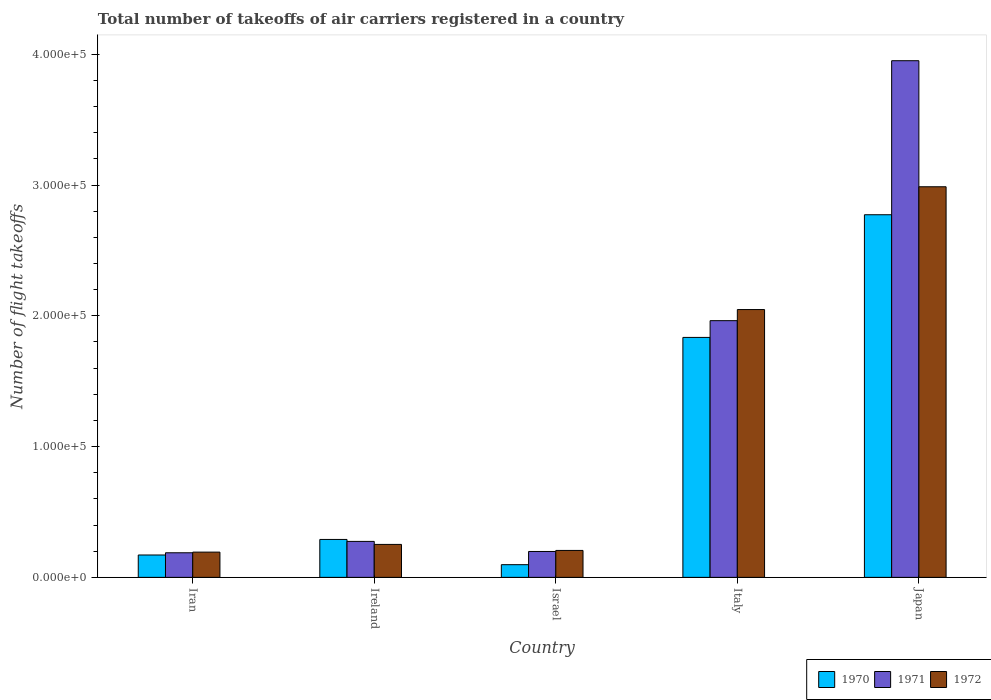How many groups of bars are there?
Ensure brevity in your answer.  5. Are the number of bars on each tick of the X-axis equal?
Your answer should be compact. Yes. How many bars are there on the 4th tick from the right?
Offer a terse response. 3. What is the label of the 2nd group of bars from the left?
Your answer should be very brief. Ireland. In how many cases, is the number of bars for a given country not equal to the number of legend labels?
Your answer should be very brief. 0. What is the total number of flight takeoffs in 1970 in Israel?
Offer a very short reply. 9700. Across all countries, what is the maximum total number of flight takeoffs in 1971?
Your answer should be very brief. 3.95e+05. Across all countries, what is the minimum total number of flight takeoffs in 1972?
Your answer should be very brief. 1.93e+04. In which country was the total number of flight takeoffs in 1971 maximum?
Provide a short and direct response. Japan. In which country was the total number of flight takeoffs in 1971 minimum?
Offer a very short reply. Iran. What is the total total number of flight takeoffs in 1972 in the graph?
Provide a succinct answer. 5.69e+05. What is the difference between the total number of flight takeoffs in 1971 in Iran and that in Japan?
Keep it short and to the point. -3.76e+05. What is the difference between the total number of flight takeoffs in 1970 in Ireland and the total number of flight takeoffs in 1971 in Israel?
Give a very brief answer. 9200. What is the average total number of flight takeoffs in 1972 per country?
Offer a very short reply. 1.14e+05. What is the difference between the total number of flight takeoffs of/in 1972 and total number of flight takeoffs of/in 1970 in Japan?
Keep it short and to the point. 2.14e+04. What is the ratio of the total number of flight takeoffs in 1972 in Iran to that in Israel?
Offer a very short reply. 0.94. What is the difference between the highest and the second highest total number of flight takeoffs in 1970?
Offer a terse response. -1.54e+05. What is the difference between the highest and the lowest total number of flight takeoffs in 1972?
Provide a succinct answer. 2.79e+05. In how many countries, is the total number of flight takeoffs in 1972 greater than the average total number of flight takeoffs in 1972 taken over all countries?
Provide a short and direct response. 2. Are the values on the major ticks of Y-axis written in scientific E-notation?
Ensure brevity in your answer.  Yes. How many legend labels are there?
Offer a very short reply. 3. What is the title of the graph?
Your response must be concise. Total number of takeoffs of air carriers registered in a country. What is the label or title of the X-axis?
Make the answer very short. Country. What is the label or title of the Y-axis?
Offer a very short reply. Number of flight takeoffs. What is the Number of flight takeoffs of 1970 in Iran?
Offer a very short reply. 1.71e+04. What is the Number of flight takeoffs in 1971 in Iran?
Offer a terse response. 1.88e+04. What is the Number of flight takeoffs of 1972 in Iran?
Your answer should be very brief. 1.93e+04. What is the Number of flight takeoffs of 1970 in Ireland?
Provide a succinct answer. 2.90e+04. What is the Number of flight takeoffs of 1971 in Ireland?
Offer a terse response. 2.75e+04. What is the Number of flight takeoffs in 1972 in Ireland?
Your answer should be compact. 2.52e+04. What is the Number of flight takeoffs of 1970 in Israel?
Provide a short and direct response. 9700. What is the Number of flight takeoffs in 1971 in Israel?
Your response must be concise. 1.98e+04. What is the Number of flight takeoffs of 1972 in Israel?
Provide a succinct answer. 2.06e+04. What is the Number of flight takeoffs in 1970 in Italy?
Your answer should be compact. 1.84e+05. What is the Number of flight takeoffs in 1971 in Italy?
Make the answer very short. 1.96e+05. What is the Number of flight takeoffs of 1972 in Italy?
Give a very brief answer. 2.05e+05. What is the Number of flight takeoffs of 1970 in Japan?
Keep it short and to the point. 2.77e+05. What is the Number of flight takeoffs of 1971 in Japan?
Offer a terse response. 3.95e+05. What is the Number of flight takeoffs of 1972 in Japan?
Your response must be concise. 2.99e+05. Across all countries, what is the maximum Number of flight takeoffs in 1970?
Your answer should be compact. 2.77e+05. Across all countries, what is the maximum Number of flight takeoffs in 1971?
Provide a short and direct response. 3.95e+05. Across all countries, what is the maximum Number of flight takeoffs of 1972?
Offer a terse response. 2.99e+05. Across all countries, what is the minimum Number of flight takeoffs of 1970?
Your answer should be very brief. 9700. Across all countries, what is the minimum Number of flight takeoffs in 1971?
Your response must be concise. 1.88e+04. Across all countries, what is the minimum Number of flight takeoffs of 1972?
Give a very brief answer. 1.93e+04. What is the total Number of flight takeoffs in 1970 in the graph?
Your answer should be very brief. 5.17e+05. What is the total Number of flight takeoffs in 1971 in the graph?
Your response must be concise. 6.58e+05. What is the total Number of flight takeoffs in 1972 in the graph?
Your response must be concise. 5.69e+05. What is the difference between the Number of flight takeoffs in 1970 in Iran and that in Ireland?
Make the answer very short. -1.19e+04. What is the difference between the Number of flight takeoffs of 1971 in Iran and that in Ireland?
Provide a succinct answer. -8700. What is the difference between the Number of flight takeoffs in 1972 in Iran and that in Ireland?
Your response must be concise. -5900. What is the difference between the Number of flight takeoffs of 1970 in Iran and that in Israel?
Offer a terse response. 7400. What is the difference between the Number of flight takeoffs in 1971 in Iran and that in Israel?
Your answer should be very brief. -1000. What is the difference between the Number of flight takeoffs of 1972 in Iran and that in Israel?
Offer a very short reply. -1300. What is the difference between the Number of flight takeoffs in 1970 in Iran and that in Italy?
Provide a short and direct response. -1.66e+05. What is the difference between the Number of flight takeoffs in 1971 in Iran and that in Italy?
Offer a terse response. -1.78e+05. What is the difference between the Number of flight takeoffs of 1972 in Iran and that in Italy?
Provide a short and direct response. -1.86e+05. What is the difference between the Number of flight takeoffs of 1970 in Iran and that in Japan?
Provide a short and direct response. -2.60e+05. What is the difference between the Number of flight takeoffs in 1971 in Iran and that in Japan?
Offer a very short reply. -3.76e+05. What is the difference between the Number of flight takeoffs of 1972 in Iran and that in Japan?
Keep it short and to the point. -2.79e+05. What is the difference between the Number of flight takeoffs in 1970 in Ireland and that in Israel?
Make the answer very short. 1.93e+04. What is the difference between the Number of flight takeoffs in 1971 in Ireland and that in Israel?
Your response must be concise. 7700. What is the difference between the Number of flight takeoffs of 1972 in Ireland and that in Israel?
Your answer should be compact. 4600. What is the difference between the Number of flight takeoffs in 1970 in Ireland and that in Italy?
Provide a succinct answer. -1.54e+05. What is the difference between the Number of flight takeoffs of 1971 in Ireland and that in Italy?
Offer a terse response. -1.69e+05. What is the difference between the Number of flight takeoffs in 1972 in Ireland and that in Italy?
Ensure brevity in your answer.  -1.80e+05. What is the difference between the Number of flight takeoffs of 1970 in Ireland and that in Japan?
Your answer should be very brief. -2.48e+05. What is the difference between the Number of flight takeoffs in 1971 in Ireland and that in Japan?
Offer a terse response. -3.68e+05. What is the difference between the Number of flight takeoffs in 1972 in Ireland and that in Japan?
Provide a short and direct response. -2.74e+05. What is the difference between the Number of flight takeoffs of 1970 in Israel and that in Italy?
Your answer should be compact. -1.74e+05. What is the difference between the Number of flight takeoffs of 1971 in Israel and that in Italy?
Your answer should be compact. -1.76e+05. What is the difference between the Number of flight takeoffs in 1972 in Israel and that in Italy?
Keep it short and to the point. -1.84e+05. What is the difference between the Number of flight takeoffs in 1970 in Israel and that in Japan?
Offer a very short reply. -2.68e+05. What is the difference between the Number of flight takeoffs in 1971 in Israel and that in Japan?
Give a very brief answer. -3.75e+05. What is the difference between the Number of flight takeoffs in 1972 in Israel and that in Japan?
Your response must be concise. -2.78e+05. What is the difference between the Number of flight takeoffs in 1970 in Italy and that in Japan?
Keep it short and to the point. -9.38e+04. What is the difference between the Number of flight takeoffs in 1971 in Italy and that in Japan?
Give a very brief answer. -1.99e+05. What is the difference between the Number of flight takeoffs in 1972 in Italy and that in Japan?
Give a very brief answer. -9.39e+04. What is the difference between the Number of flight takeoffs in 1970 in Iran and the Number of flight takeoffs in 1971 in Ireland?
Ensure brevity in your answer.  -1.04e+04. What is the difference between the Number of flight takeoffs of 1970 in Iran and the Number of flight takeoffs of 1972 in Ireland?
Provide a short and direct response. -8100. What is the difference between the Number of flight takeoffs of 1971 in Iran and the Number of flight takeoffs of 1972 in Ireland?
Your response must be concise. -6400. What is the difference between the Number of flight takeoffs of 1970 in Iran and the Number of flight takeoffs of 1971 in Israel?
Provide a succinct answer. -2700. What is the difference between the Number of flight takeoffs of 1970 in Iran and the Number of flight takeoffs of 1972 in Israel?
Your answer should be very brief. -3500. What is the difference between the Number of flight takeoffs in 1971 in Iran and the Number of flight takeoffs in 1972 in Israel?
Offer a terse response. -1800. What is the difference between the Number of flight takeoffs of 1970 in Iran and the Number of flight takeoffs of 1971 in Italy?
Offer a very short reply. -1.79e+05. What is the difference between the Number of flight takeoffs of 1970 in Iran and the Number of flight takeoffs of 1972 in Italy?
Keep it short and to the point. -1.88e+05. What is the difference between the Number of flight takeoffs of 1971 in Iran and the Number of flight takeoffs of 1972 in Italy?
Your answer should be very brief. -1.86e+05. What is the difference between the Number of flight takeoffs in 1970 in Iran and the Number of flight takeoffs in 1971 in Japan?
Your answer should be compact. -3.78e+05. What is the difference between the Number of flight takeoffs of 1970 in Iran and the Number of flight takeoffs of 1972 in Japan?
Provide a succinct answer. -2.82e+05. What is the difference between the Number of flight takeoffs in 1971 in Iran and the Number of flight takeoffs in 1972 in Japan?
Offer a very short reply. -2.80e+05. What is the difference between the Number of flight takeoffs of 1970 in Ireland and the Number of flight takeoffs of 1971 in Israel?
Offer a terse response. 9200. What is the difference between the Number of flight takeoffs in 1970 in Ireland and the Number of flight takeoffs in 1972 in Israel?
Offer a terse response. 8400. What is the difference between the Number of flight takeoffs in 1971 in Ireland and the Number of flight takeoffs in 1972 in Israel?
Your response must be concise. 6900. What is the difference between the Number of flight takeoffs in 1970 in Ireland and the Number of flight takeoffs in 1971 in Italy?
Provide a succinct answer. -1.67e+05. What is the difference between the Number of flight takeoffs in 1970 in Ireland and the Number of flight takeoffs in 1972 in Italy?
Provide a succinct answer. -1.76e+05. What is the difference between the Number of flight takeoffs in 1971 in Ireland and the Number of flight takeoffs in 1972 in Italy?
Offer a very short reply. -1.77e+05. What is the difference between the Number of flight takeoffs of 1970 in Ireland and the Number of flight takeoffs of 1971 in Japan?
Your answer should be compact. -3.66e+05. What is the difference between the Number of flight takeoffs in 1970 in Ireland and the Number of flight takeoffs in 1972 in Japan?
Ensure brevity in your answer.  -2.70e+05. What is the difference between the Number of flight takeoffs in 1971 in Ireland and the Number of flight takeoffs in 1972 in Japan?
Your answer should be very brief. -2.71e+05. What is the difference between the Number of flight takeoffs of 1970 in Israel and the Number of flight takeoffs of 1971 in Italy?
Your response must be concise. -1.87e+05. What is the difference between the Number of flight takeoffs in 1970 in Israel and the Number of flight takeoffs in 1972 in Italy?
Provide a short and direct response. -1.95e+05. What is the difference between the Number of flight takeoffs in 1971 in Israel and the Number of flight takeoffs in 1972 in Italy?
Give a very brief answer. -1.85e+05. What is the difference between the Number of flight takeoffs of 1970 in Israel and the Number of flight takeoffs of 1971 in Japan?
Keep it short and to the point. -3.85e+05. What is the difference between the Number of flight takeoffs of 1970 in Israel and the Number of flight takeoffs of 1972 in Japan?
Your answer should be very brief. -2.89e+05. What is the difference between the Number of flight takeoffs in 1971 in Israel and the Number of flight takeoffs in 1972 in Japan?
Your answer should be compact. -2.79e+05. What is the difference between the Number of flight takeoffs in 1970 in Italy and the Number of flight takeoffs in 1971 in Japan?
Offer a very short reply. -2.12e+05. What is the difference between the Number of flight takeoffs of 1970 in Italy and the Number of flight takeoffs of 1972 in Japan?
Your answer should be compact. -1.15e+05. What is the difference between the Number of flight takeoffs in 1971 in Italy and the Number of flight takeoffs in 1972 in Japan?
Keep it short and to the point. -1.02e+05. What is the average Number of flight takeoffs in 1970 per country?
Your answer should be very brief. 1.03e+05. What is the average Number of flight takeoffs of 1971 per country?
Offer a very short reply. 1.32e+05. What is the average Number of flight takeoffs of 1972 per country?
Your answer should be very brief. 1.14e+05. What is the difference between the Number of flight takeoffs in 1970 and Number of flight takeoffs in 1971 in Iran?
Keep it short and to the point. -1700. What is the difference between the Number of flight takeoffs of 1970 and Number of flight takeoffs of 1972 in Iran?
Give a very brief answer. -2200. What is the difference between the Number of flight takeoffs in 1971 and Number of flight takeoffs in 1972 in Iran?
Keep it short and to the point. -500. What is the difference between the Number of flight takeoffs in 1970 and Number of flight takeoffs in 1971 in Ireland?
Offer a terse response. 1500. What is the difference between the Number of flight takeoffs in 1970 and Number of flight takeoffs in 1972 in Ireland?
Your response must be concise. 3800. What is the difference between the Number of flight takeoffs of 1971 and Number of flight takeoffs of 1972 in Ireland?
Offer a terse response. 2300. What is the difference between the Number of flight takeoffs of 1970 and Number of flight takeoffs of 1971 in Israel?
Give a very brief answer. -1.01e+04. What is the difference between the Number of flight takeoffs in 1970 and Number of flight takeoffs in 1972 in Israel?
Offer a very short reply. -1.09e+04. What is the difference between the Number of flight takeoffs in 1971 and Number of flight takeoffs in 1972 in Israel?
Your response must be concise. -800. What is the difference between the Number of flight takeoffs in 1970 and Number of flight takeoffs in 1971 in Italy?
Ensure brevity in your answer.  -1.28e+04. What is the difference between the Number of flight takeoffs in 1970 and Number of flight takeoffs in 1972 in Italy?
Offer a terse response. -2.13e+04. What is the difference between the Number of flight takeoffs in 1971 and Number of flight takeoffs in 1972 in Italy?
Give a very brief answer. -8500. What is the difference between the Number of flight takeoffs of 1970 and Number of flight takeoffs of 1971 in Japan?
Offer a terse response. -1.18e+05. What is the difference between the Number of flight takeoffs of 1970 and Number of flight takeoffs of 1972 in Japan?
Offer a terse response. -2.14e+04. What is the difference between the Number of flight takeoffs of 1971 and Number of flight takeoffs of 1972 in Japan?
Offer a terse response. 9.64e+04. What is the ratio of the Number of flight takeoffs in 1970 in Iran to that in Ireland?
Provide a succinct answer. 0.59. What is the ratio of the Number of flight takeoffs of 1971 in Iran to that in Ireland?
Give a very brief answer. 0.68. What is the ratio of the Number of flight takeoffs in 1972 in Iran to that in Ireland?
Make the answer very short. 0.77. What is the ratio of the Number of flight takeoffs in 1970 in Iran to that in Israel?
Your response must be concise. 1.76. What is the ratio of the Number of flight takeoffs of 1971 in Iran to that in Israel?
Offer a very short reply. 0.95. What is the ratio of the Number of flight takeoffs in 1972 in Iran to that in Israel?
Provide a short and direct response. 0.94. What is the ratio of the Number of flight takeoffs of 1970 in Iran to that in Italy?
Provide a succinct answer. 0.09. What is the ratio of the Number of flight takeoffs of 1971 in Iran to that in Italy?
Provide a short and direct response. 0.1. What is the ratio of the Number of flight takeoffs of 1972 in Iran to that in Italy?
Provide a short and direct response. 0.09. What is the ratio of the Number of flight takeoffs of 1970 in Iran to that in Japan?
Provide a short and direct response. 0.06. What is the ratio of the Number of flight takeoffs of 1971 in Iran to that in Japan?
Your response must be concise. 0.05. What is the ratio of the Number of flight takeoffs of 1972 in Iran to that in Japan?
Ensure brevity in your answer.  0.06. What is the ratio of the Number of flight takeoffs in 1970 in Ireland to that in Israel?
Give a very brief answer. 2.99. What is the ratio of the Number of flight takeoffs in 1971 in Ireland to that in Israel?
Keep it short and to the point. 1.39. What is the ratio of the Number of flight takeoffs of 1972 in Ireland to that in Israel?
Offer a very short reply. 1.22. What is the ratio of the Number of flight takeoffs of 1970 in Ireland to that in Italy?
Offer a terse response. 0.16. What is the ratio of the Number of flight takeoffs of 1971 in Ireland to that in Italy?
Provide a succinct answer. 0.14. What is the ratio of the Number of flight takeoffs in 1972 in Ireland to that in Italy?
Offer a very short reply. 0.12. What is the ratio of the Number of flight takeoffs of 1970 in Ireland to that in Japan?
Ensure brevity in your answer.  0.1. What is the ratio of the Number of flight takeoffs of 1971 in Ireland to that in Japan?
Your response must be concise. 0.07. What is the ratio of the Number of flight takeoffs in 1972 in Ireland to that in Japan?
Keep it short and to the point. 0.08. What is the ratio of the Number of flight takeoffs in 1970 in Israel to that in Italy?
Make the answer very short. 0.05. What is the ratio of the Number of flight takeoffs in 1971 in Israel to that in Italy?
Provide a short and direct response. 0.1. What is the ratio of the Number of flight takeoffs in 1972 in Israel to that in Italy?
Provide a succinct answer. 0.1. What is the ratio of the Number of flight takeoffs of 1970 in Israel to that in Japan?
Ensure brevity in your answer.  0.04. What is the ratio of the Number of flight takeoffs of 1971 in Israel to that in Japan?
Your answer should be very brief. 0.05. What is the ratio of the Number of flight takeoffs of 1972 in Israel to that in Japan?
Provide a short and direct response. 0.07. What is the ratio of the Number of flight takeoffs in 1970 in Italy to that in Japan?
Keep it short and to the point. 0.66. What is the ratio of the Number of flight takeoffs of 1971 in Italy to that in Japan?
Keep it short and to the point. 0.5. What is the ratio of the Number of flight takeoffs of 1972 in Italy to that in Japan?
Provide a short and direct response. 0.69. What is the difference between the highest and the second highest Number of flight takeoffs in 1970?
Keep it short and to the point. 9.38e+04. What is the difference between the highest and the second highest Number of flight takeoffs in 1971?
Your answer should be very brief. 1.99e+05. What is the difference between the highest and the second highest Number of flight takeoffs in 1972?
Provide a short and direct response. 9.39e+04. What is the difference between the highest and the lowest Number of flight takeoffs of 1970?
Give a very brief answer. 2.68e+05. What is the difference between the highest and the lowest Number of flight takeoffs in 1971?
Make the answer very short. 3.76e+05. What is the difference between the highest and the lowest Number of flight takeoffs of 1972?
Your answer should be compact. 2.79e+05. 